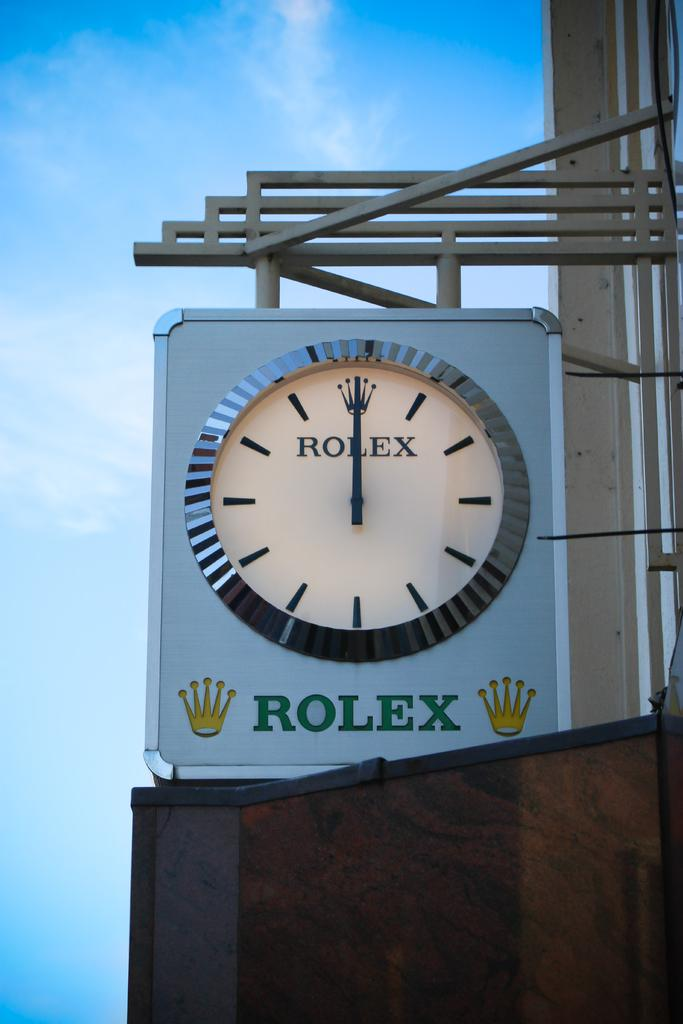<image>
Render a clear and concise summary of the photo. A clock by Rolex that says Rolex on the face of the clock and below it. 